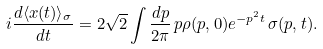Convert formula to latex. <formula><loc_0><loc_0><loc_500><loc_500>i \frac { d \langle x ( t ) \rangle _ { \sigma } } { d t } = 2 \sqrt { 2 } \int \frac { d p } { 2 \pi } \, p \rho ( p , 0 ) e ^ { - p ^ { 2 } t } \, \sigma ( p , t ) .</formula> 